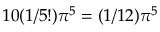<formula> <loc_0><loc_0><loc_500><loc_500>1 0 ( 1 / 5 ! ) \pi ^ { 5 } = ( 1 / 1 2 ) \pi ^ { 5 }</formula> 